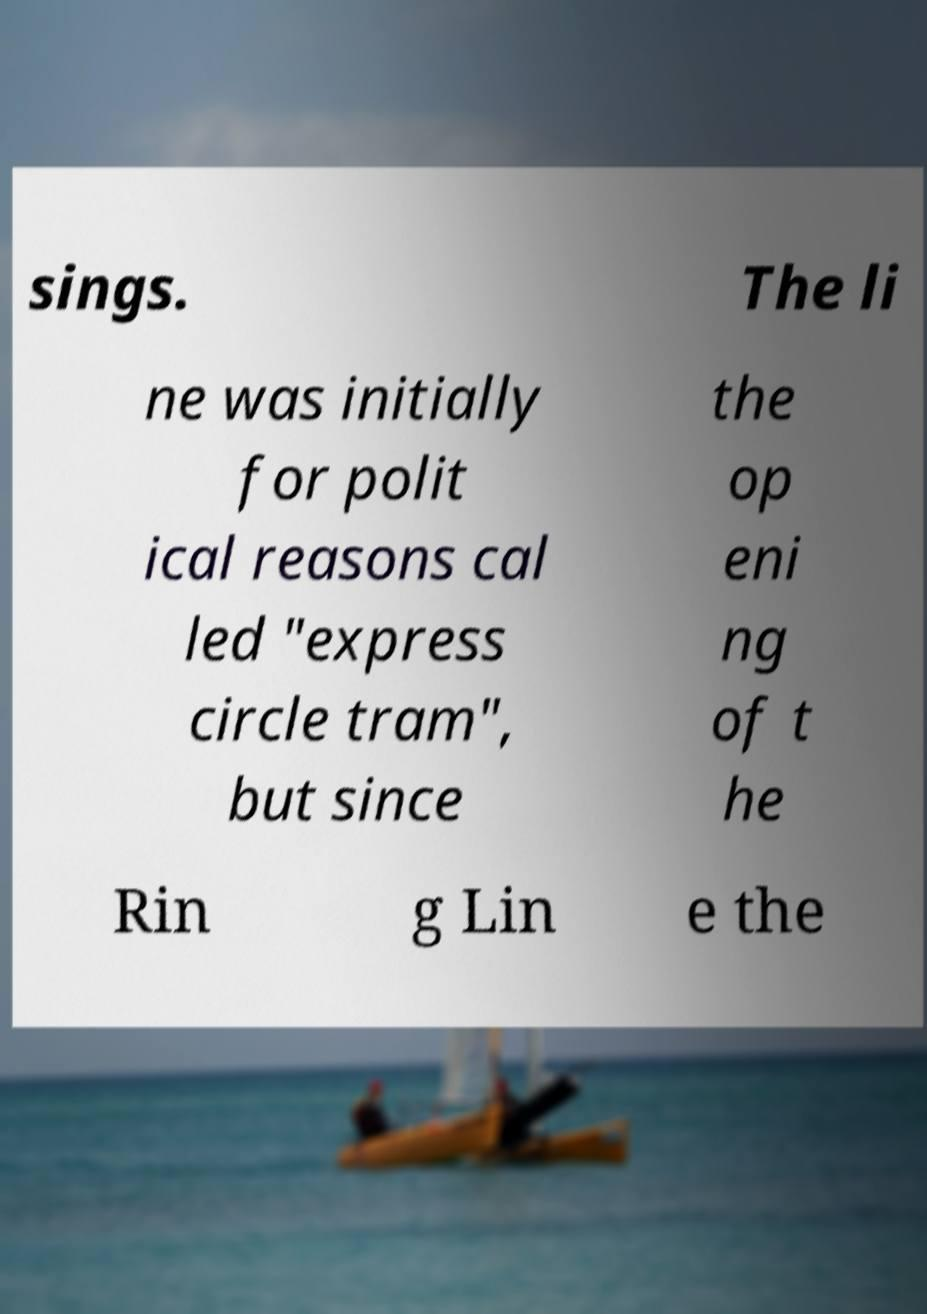Can you accurately transcribe the text from the provided image for me? sings. The li ne was initially for polit ical reasons cal led "express circle tram", but since the op eni ng of t he Rin g Lin e the 